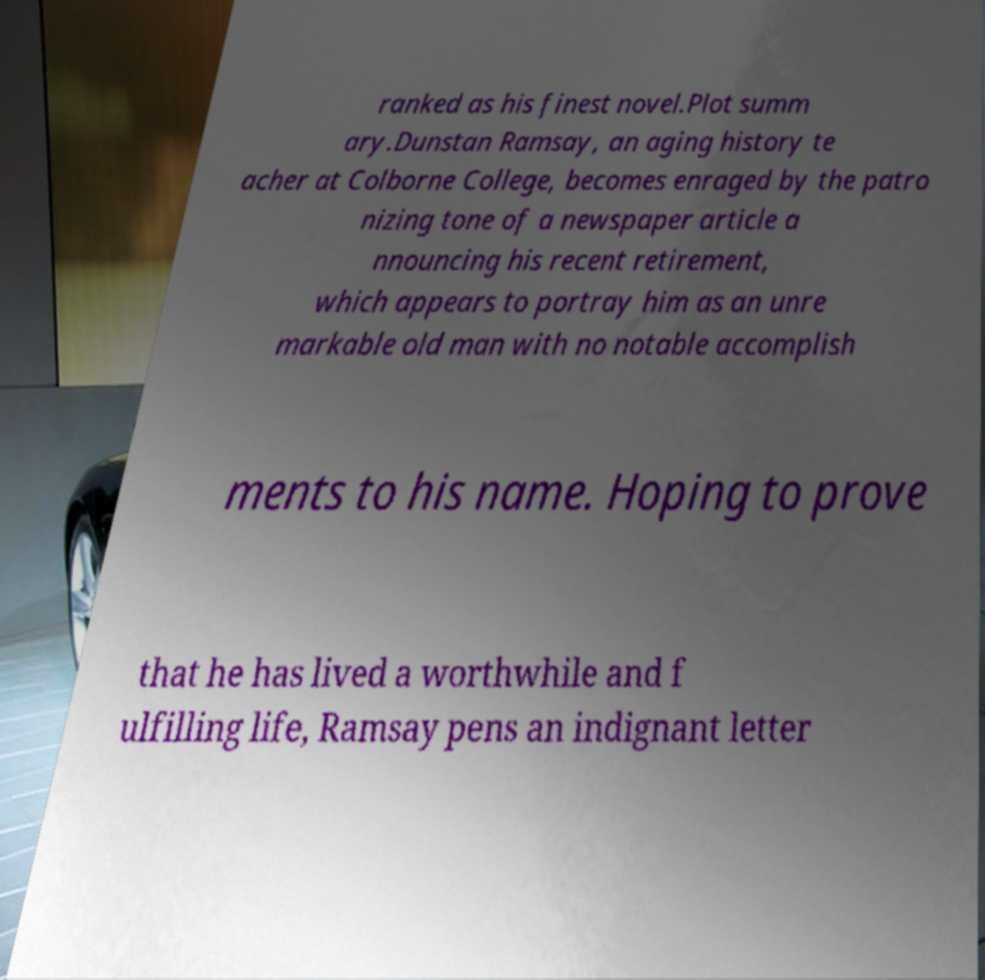Could you assist in decoding the text presented in this image and type it out clearly? ranked as his finest novel.Plot summ ary.Dunstan Ramsay, an aging history te acher at Colborne College, becomes enraged by the patro nizing tone of a newspaper article a nnouncing his recent retirement, which appears to portray him as an unre markable old man with no notable accomplish ments to his name. Hoping to prove that he has lived a worthwhile and f ulfilling life, Ramsay pens an indignant letter 